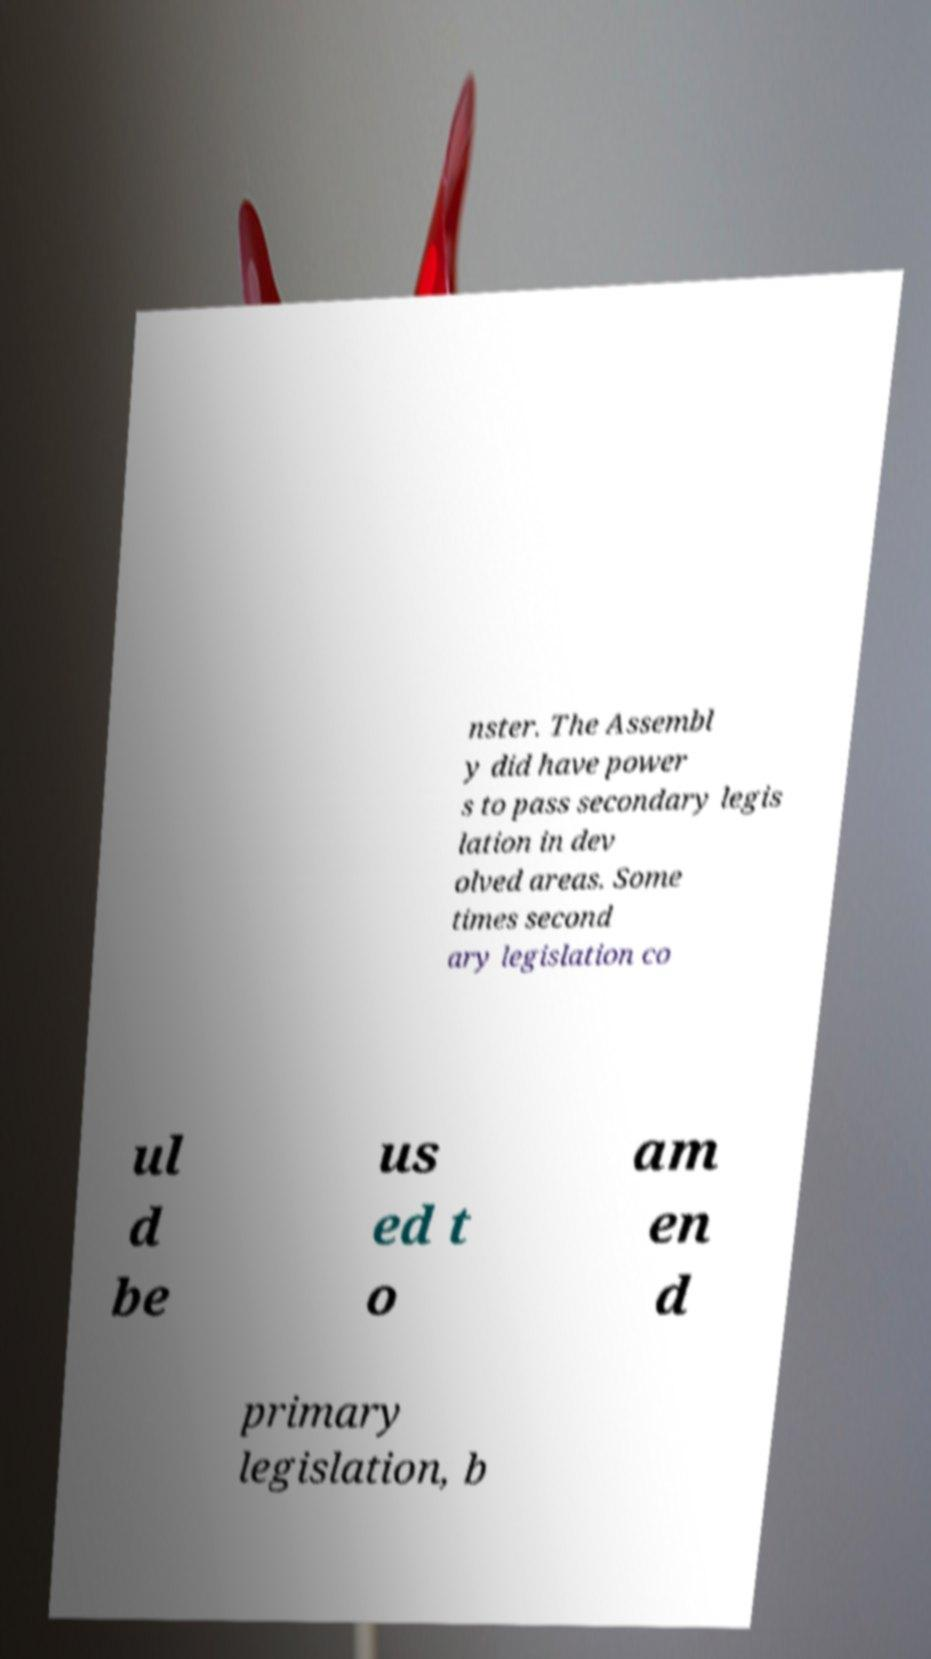Could you assist in decoding the text presented in this image and type it out clearly? nster. The Assembl y did have power s to pass secondary legis lation in dev olved areas. Some times second ary legislation co ul d be us ed t o am en d primary legislation, b 